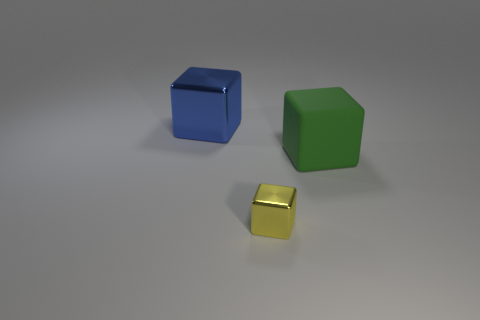Are there any other things that are made of the same material as the green object?
Keep it short and to the point. No. There is a big cube to the left of the matte thing; what number of small yellow shiny things are in front of it?
Your answer should be compact. 1. How many other blue objects are the same material as the blue thing?
Provide a short and direct response. 0. Are there any large rubber objects behind the blue metallic block?
Ensure brevity in your answer.  No. There is another thing that is the same size as the green thing; what is its color?
Give a very brief answer. Blue. How many objects are big cubes left of the big rubber cube or blue matte spheres?
Make the answer very short. 1. There is a object that is both in front of the large blue thing and to the left of the matte object; what size is it?
Offer a terse response. Small. What number of other things are the same size as the green block?
Provide a succinct answer. 1. The metal block behind the metallic thing that is in front of the shiny block that is behind the small metallic cube is what color?
Your answer should be very brief. Blue. How many other things are the same shape as the small object?
Offer a very short reply. 2. 